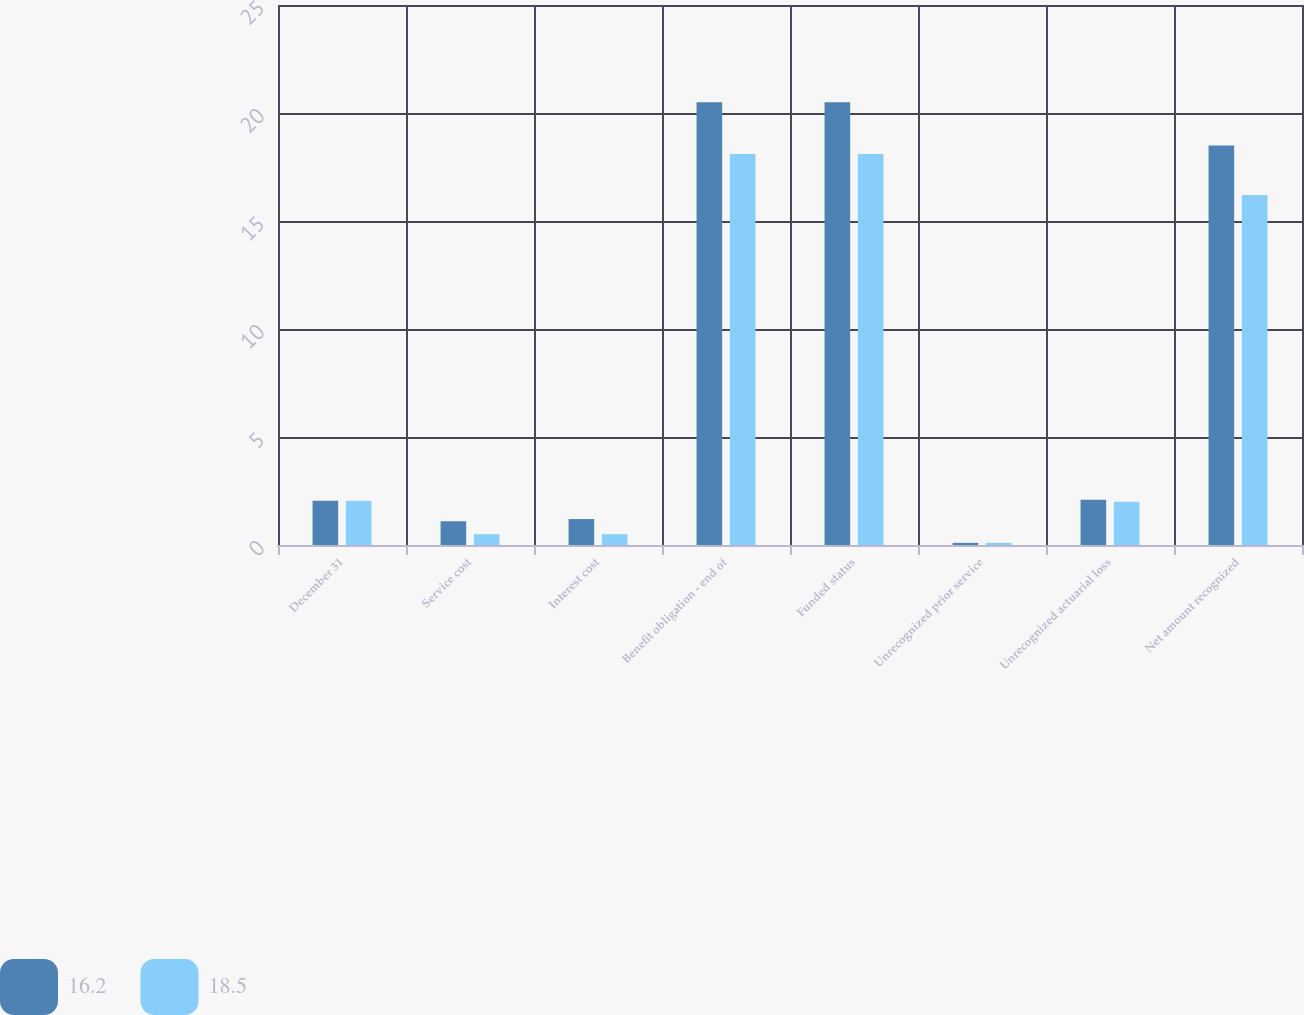Convert chart to OTSL. <chart><loc_0><loc_0><loc_500><loc_500><stacked_bar_chart><ecel><fcel>December 31<fcel>Service cost<fcel>Interest cost<fcel>Benefit obligation - end of<fcel>Funded status<fcel>Unrecognized prior service<fcel>Unrecognized actuarial loss<fcel>Net amount recognized<nl><fcel>16.2<fcel>2.05<fcel>1.1<fcel>1.2<fcel>20.5<fcel>20.5<fcel>0.1<fcel>2.1<fcel>18.5<nl><fcel>18.5<fcel>2.05<fcel>0.5<fcel>0.5<fcel>18.1<fcel>18.1<fcel>0.1<fcel>2<fcel>16.2<nl></chart> 